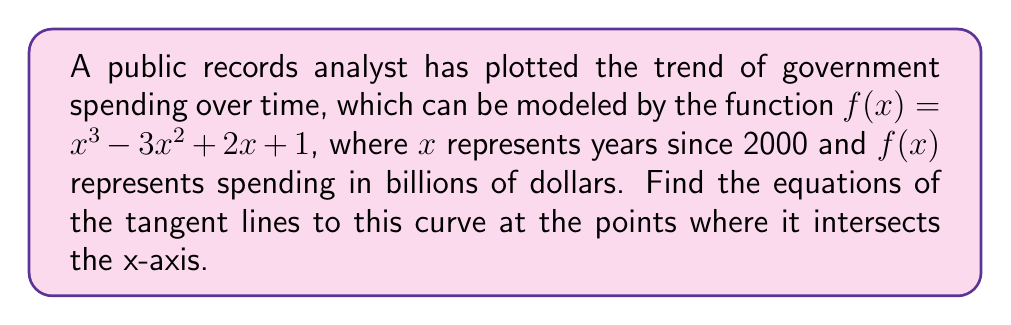Help me with this question. 1) First, we need to find the x-intercepts of the curve. These are the points where $f(x) = 0$:

   $x^3 - 3x^2 + 2x + 1 = 0$

   This can be factored as: $(x - 1)^2(x - 1) = 0$

   So, the x-intercepts are at $x = 1$ (with multiplicity 2) and $x = 1$.

2) To find the tangent lines, we need to calculate $f'(x)$:

   $f'(x) = 3x^2 - 6x + 2$

3) At $x = 1$, we calculate the slope of the tangent line:

   $f'(1) = 3(1)^2 - 6(1) + 2 = 3 - 6 + 2 = -1$

4) We can find the y-coordinate of the point by plugging $x = 1$ into $f(x)$:

   $f(1) = 1^3 - 3(1)^2 + 2(1) + 1 = 1 - 3 + 2 + 1 = 1$

   So, the point of tangency is $(1, 0)$.

5) Using the point-slope form of a line, the equation of the tangent line is:

   $y - 0 = -1(x - 1)$

   Simplifying: $y = -x + 1$

6) Since there is only one distinct x-intercept (with multiplicity 2), there is only one tangent line equation.
Answer: $y = -x + 1$ 